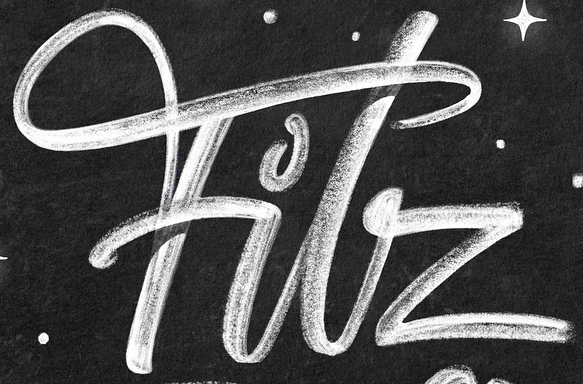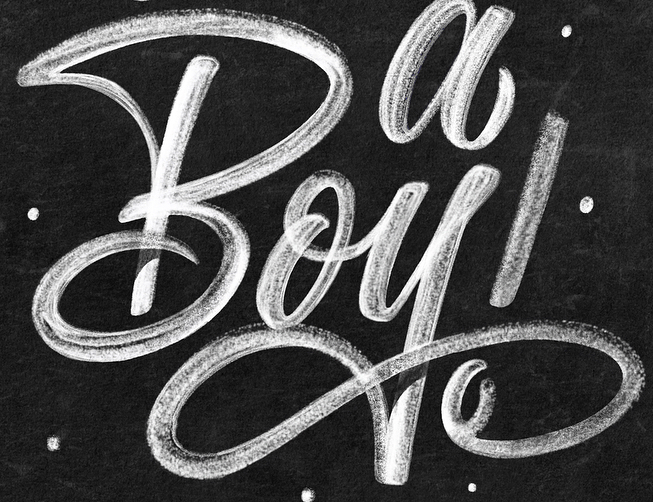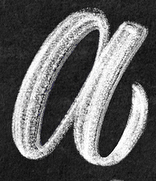What text appears in these images from left to right, separated by a semicolon? Filz; Boy!; a 